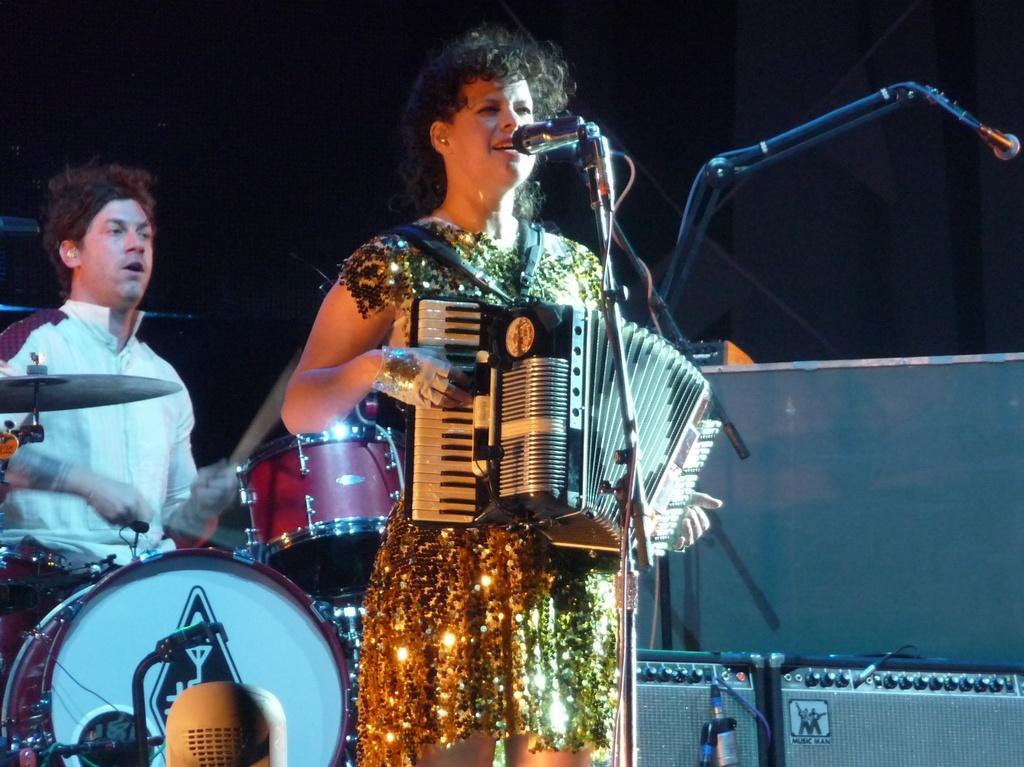Please provide a concise description of this image. A woman is standing and playing the musical instrument, she wore a golden color dress. In the left side a man is beating the drums. He wore a white color shirt. 